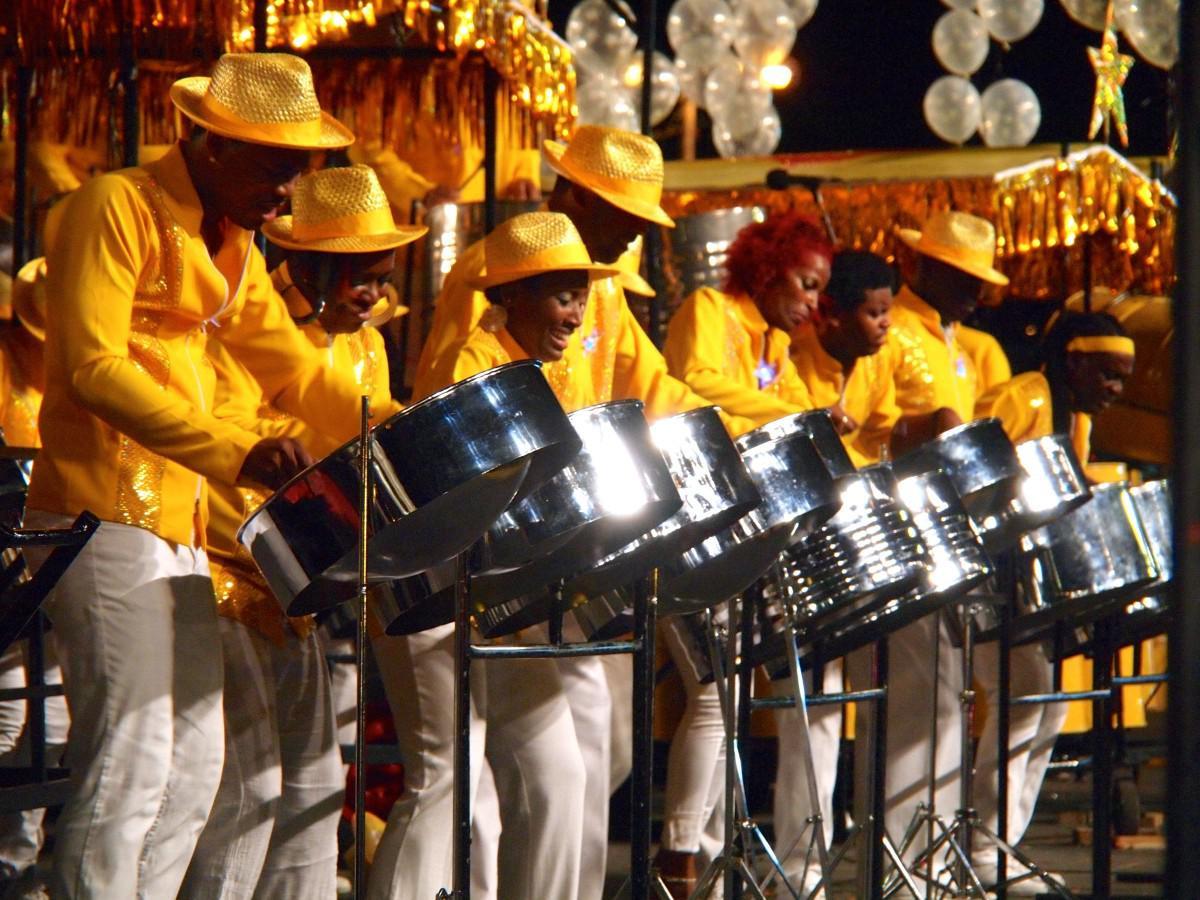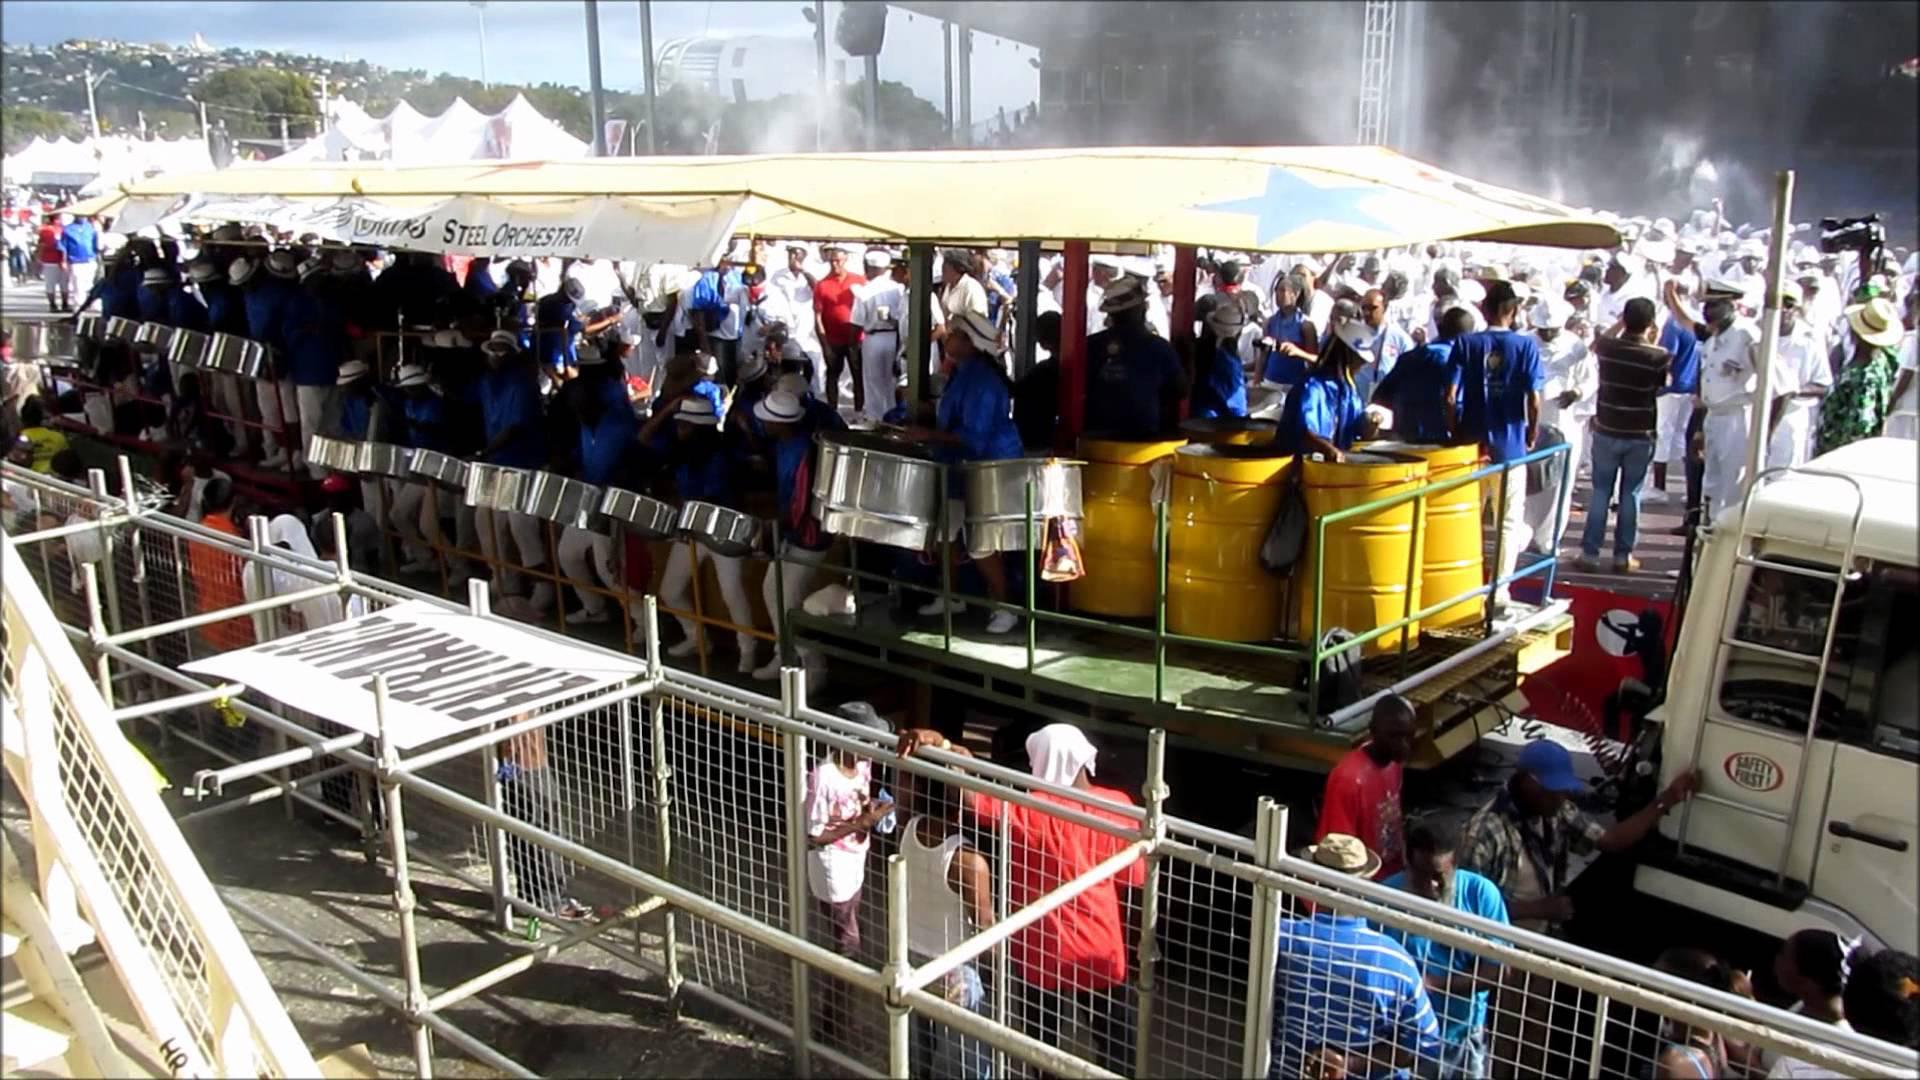The first image is the image on the left, the second image is the image on the right. For the images displayed, is the sentence "In the image to the right, people wearing white shirts are banging steel drum instruments." factually correct? Answer yes or no. No. The first image is the image on the left, the second image is the image on the right. Considering the images on both sides, is "The foreground of one image features a row of at least three forward-turned people in red shirts bending over silver drums." valid? Answer yes or no. No. 